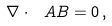<formula> <loc_0><loc_0><loc_500><loc_500>\nabla \cdot \ A { B } = 0 \, ,</formula> 